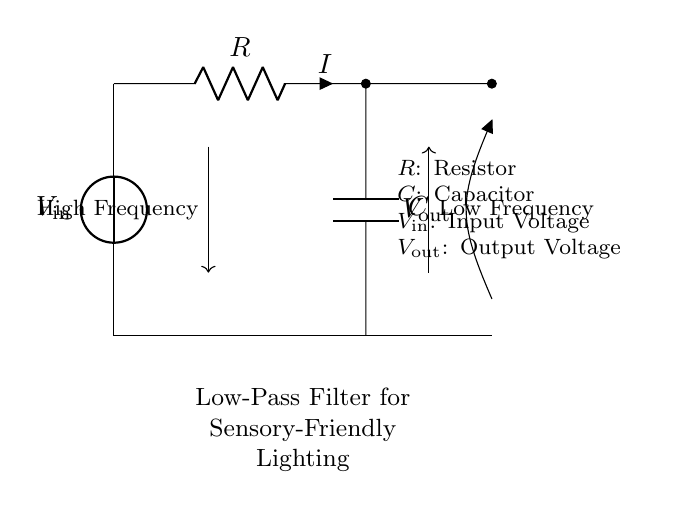What are the components in the circuit? The circuit consists of a voltage source, a resistor, and a capacitor. These are identifiable in the diagram; the voltage source is labeled as V_in, the resistor as R, and the capacitor as C.
Answer: Voltage source, resistor, capacitor What does V_out represent in this circuit? V_out represents the output voltage of the circuit, which can be measured across the capacitor. It is the voltage that is affected by the low-pass filtering action of the circuit.
Answer: Output voltage What happens to high frequency signals in this circuit? High frequency signals are attenuated, meaning their amplitude is reduced. This occurs because the capacitor charges and discharges more quickly, preventing high-frequency signals from passing through effectively.
Answer: Attenuated What is the role of the resistor in the low-pass filter? The resistor limits the current flow and works together with the capacitor to set the cutoff frequency, allowing low-frequency signals to pass while blocking higher-frequency ones.
Answer: Limits current flow How does the combination of R and C affect the filter’s behavior? The values of R (resistor) and C (capacitor) determine the cutoff frequency of the filter, which defines the point at which frequencies above it are attenuated. The formula for the cutoff frequency is 1/(2πRC).
Answer: Cutoff frequency 